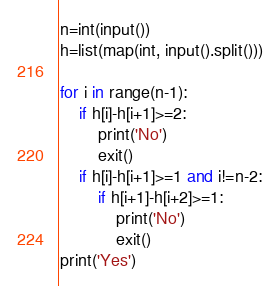Convert code to text. <code><loc_0><loc_0><loc_500><loc_500><_Python_>n=int(input())
h=list(map(int, input().split()))

for i in range(n-1):
    if h[i]-h[i+1]>=2:
        print('No')
        exit()
    if h[i]-h[i+1]>=1 and i!=n-2:
        if h[i+1]-h[i+2]>=1:
            print('No')
            exit()
print('Yes')</code> 